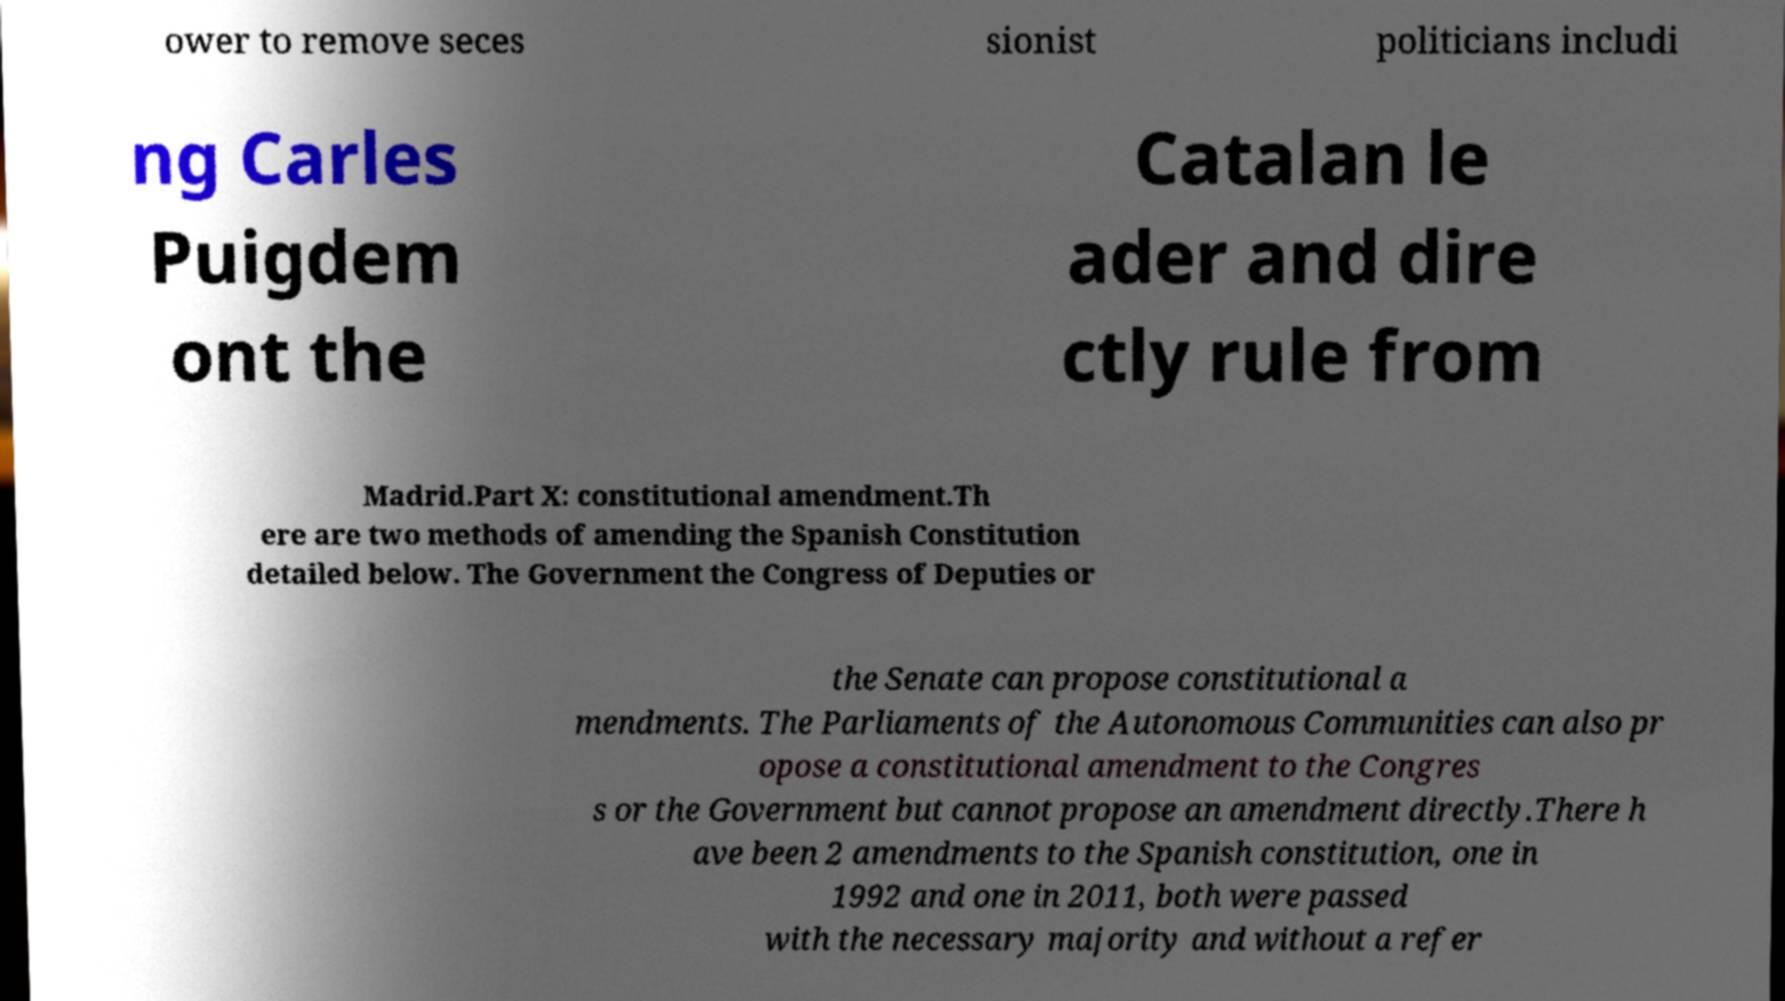For documentation purposes, I need the text within this image transcribed. Could you provide that? ower to remove seces sionist politicians includi ng Carles Puigdem ont the Catalan le ader and dire ctly rule from Madrid.Part X: constitutional amendment.Th ere are two methods of amending the Spanish Constitution detailed below. The Government the Congress of Deputies or the Senate can propose constitutional a mendments. The Parliaments of the Autonomous Communities can also pr opose a constitutional amendment to the Congres s or the Government but cannot propose an amendment directly.There h ave been 2 amendments to the Spanish constitution, one in 1992 and one in 2011, both were passed with the necessary majority and without a refer 